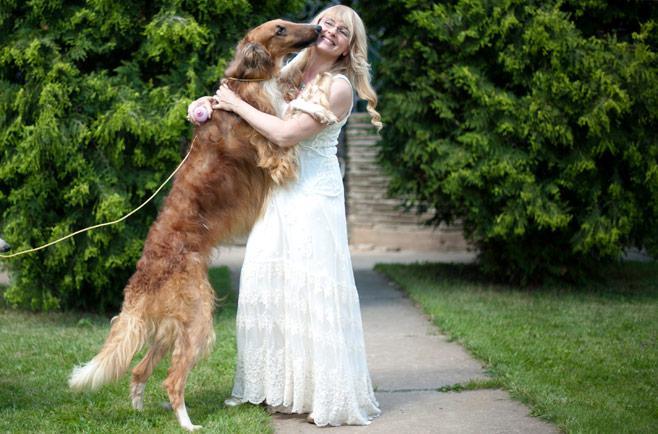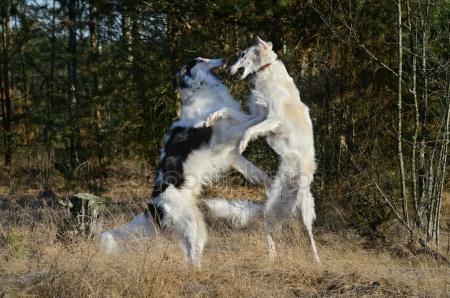The first image is the image on the left, the second image is the image on the right. Considering the images on both sides, is "There are no more than two dogs in the right image standing on green grass." valid? Answer yes or no. No. The first image is the image on the left, the second image is the image on the right. For the images shown, is this caption "At least three people, including one in bright red, stand in a row behind dogs standing on grass." true? Answer yes or no. No. 